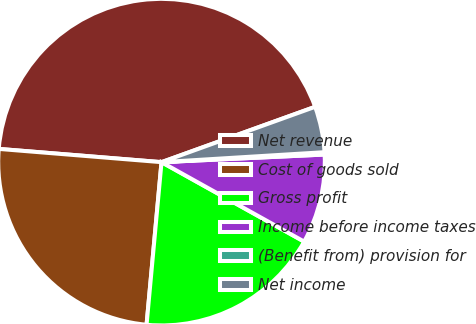Convert chart. <chart><loc_0><loc_0><loc_500><loc_500><pie_chart><fcel>Net revenue<fcel>Cost of goods sold<fcel>Gross profit<fcel>Income before income taxes<fcel>(Benefit from) provision for<fcel>Net income<nl><fcel>43.2%<fcel>24.83%<fcel>18.37%<fcel>8.83%<fcel>0.23%<fcel>4.53%<nl></chart> 